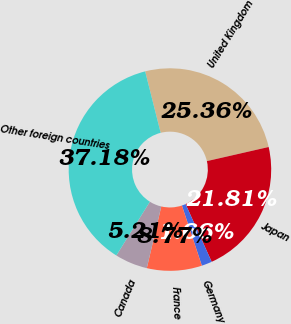Convert chart to OTSL. <chart><loc_0><loc_0><loc_500><loc_500><pie_chart><fcel>United Kingdom<fcel>Japan<fcel>Germany<fcel>France<fcel>Canada<fcel>Other foreign countries<nl><fcel>25.36%<fcel>21.81%<fcel>1.66%<fcel>8.77%<fcel>5.21%<fcel>37.18%<nl></chart> 